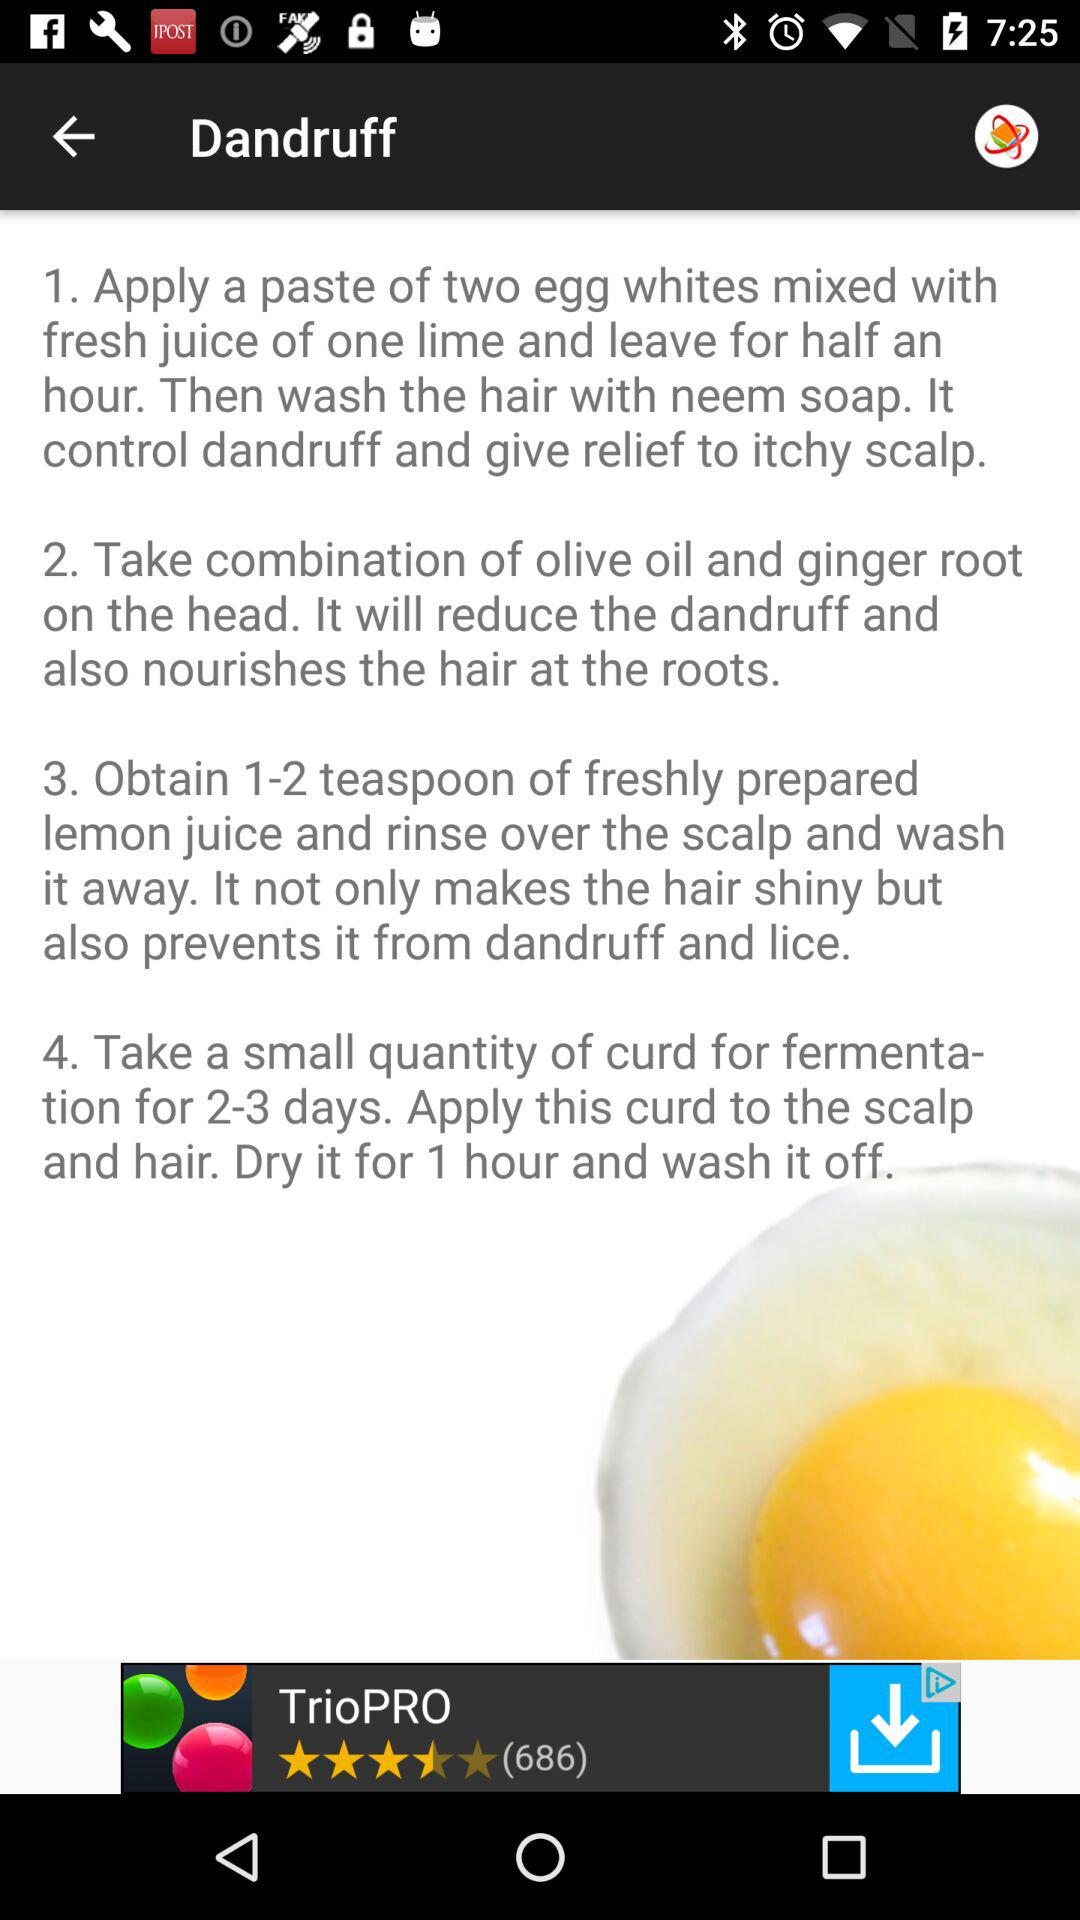How many eggs are needed? There are 2 eggs needed. 